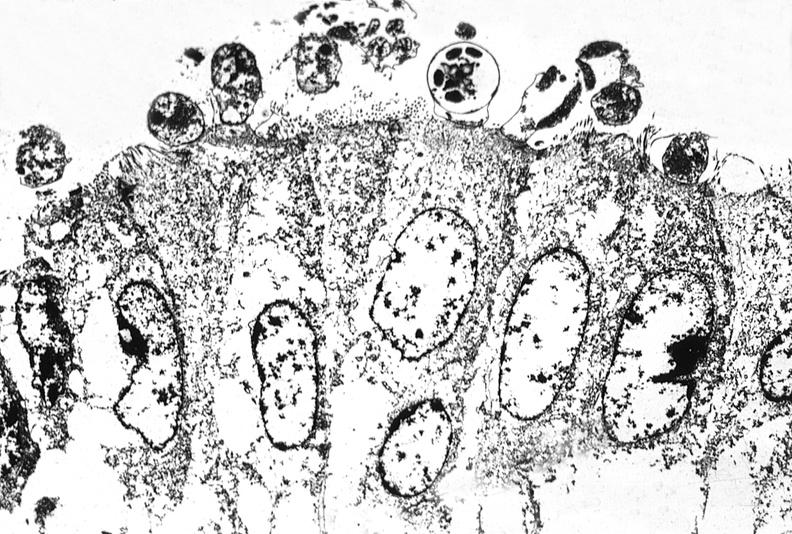what does this image show?
Answer the question using a single word or phrase. Colon biopsy 